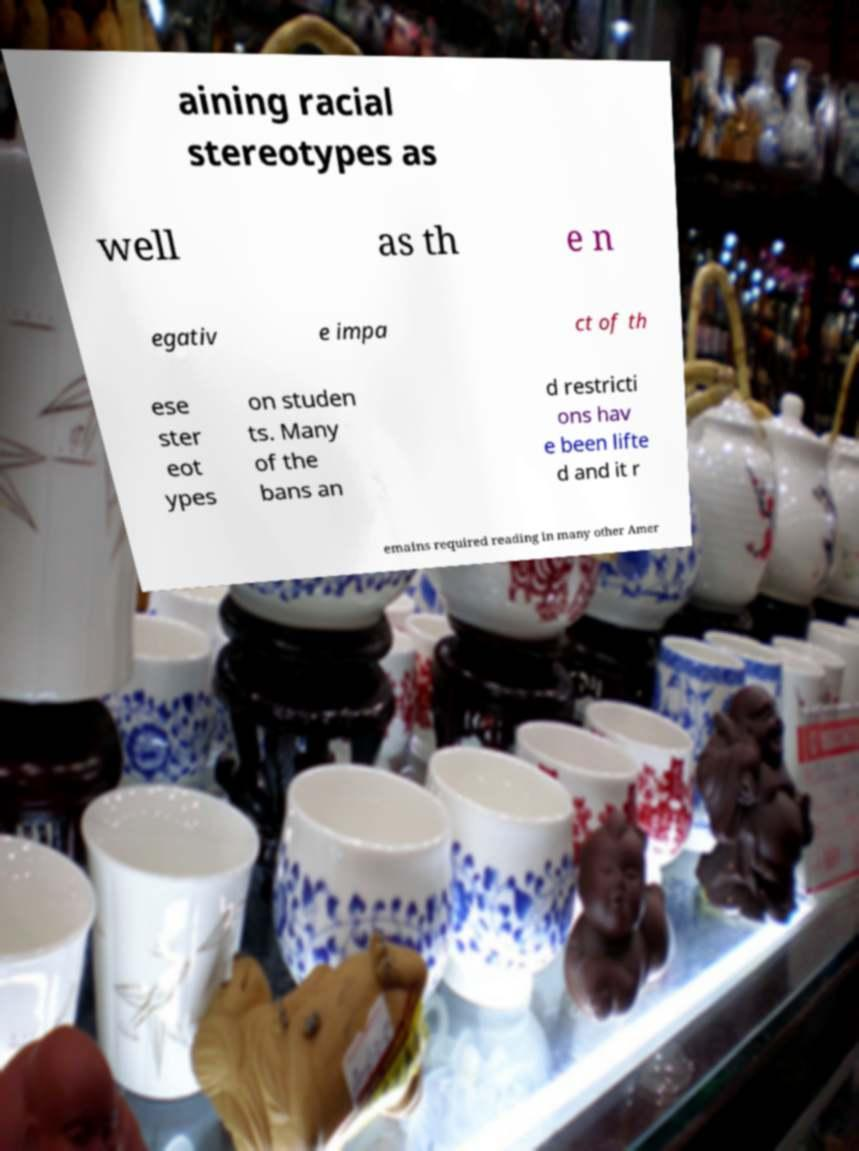What messages or text are displayed in this image? I need them in a readable, typed format. aining racial stereotypes as well as th e n egativ e impa ct of th ese ster eot ypes on studen ts. Many of the bans an d restricti ons hav e been lifte d and it r emains required reading in many other Amer 